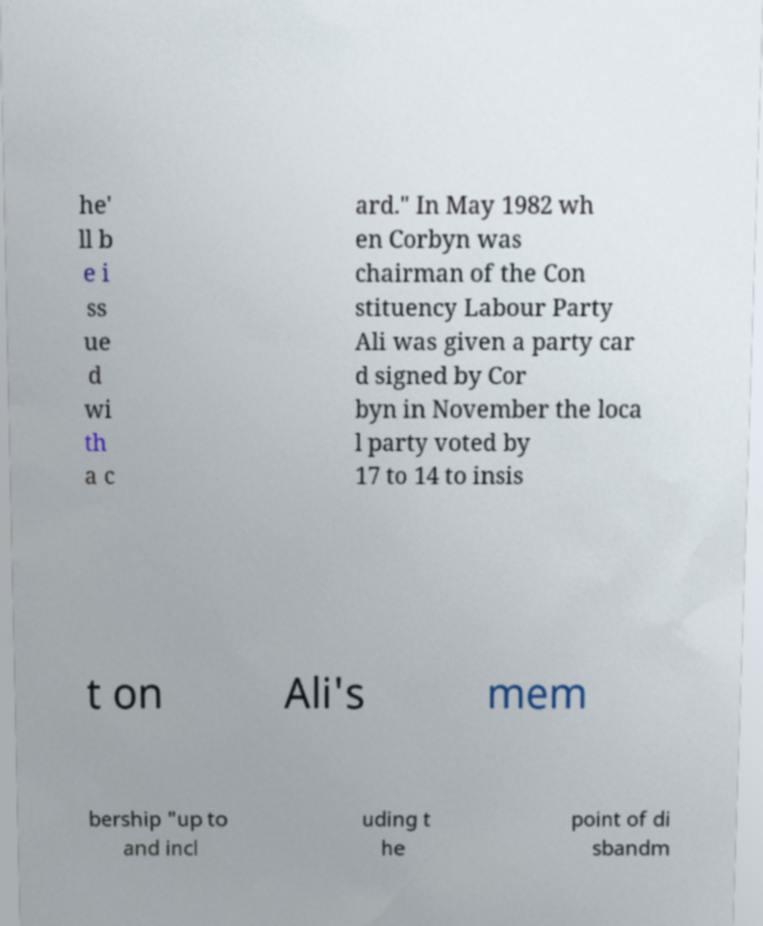Please read and relay the text visible in this image. What does it say? he' ll b e i ss ue d wi th a c ard." In May 1982 wh en Corbyn was chairman of the Con stituency Labour Party Ali was given a party car d signed by Cor byn in November the loca l party voted by 17 to 14 to insis t on Ali's mem bership "up to and incl uding t he point of di sbandm 